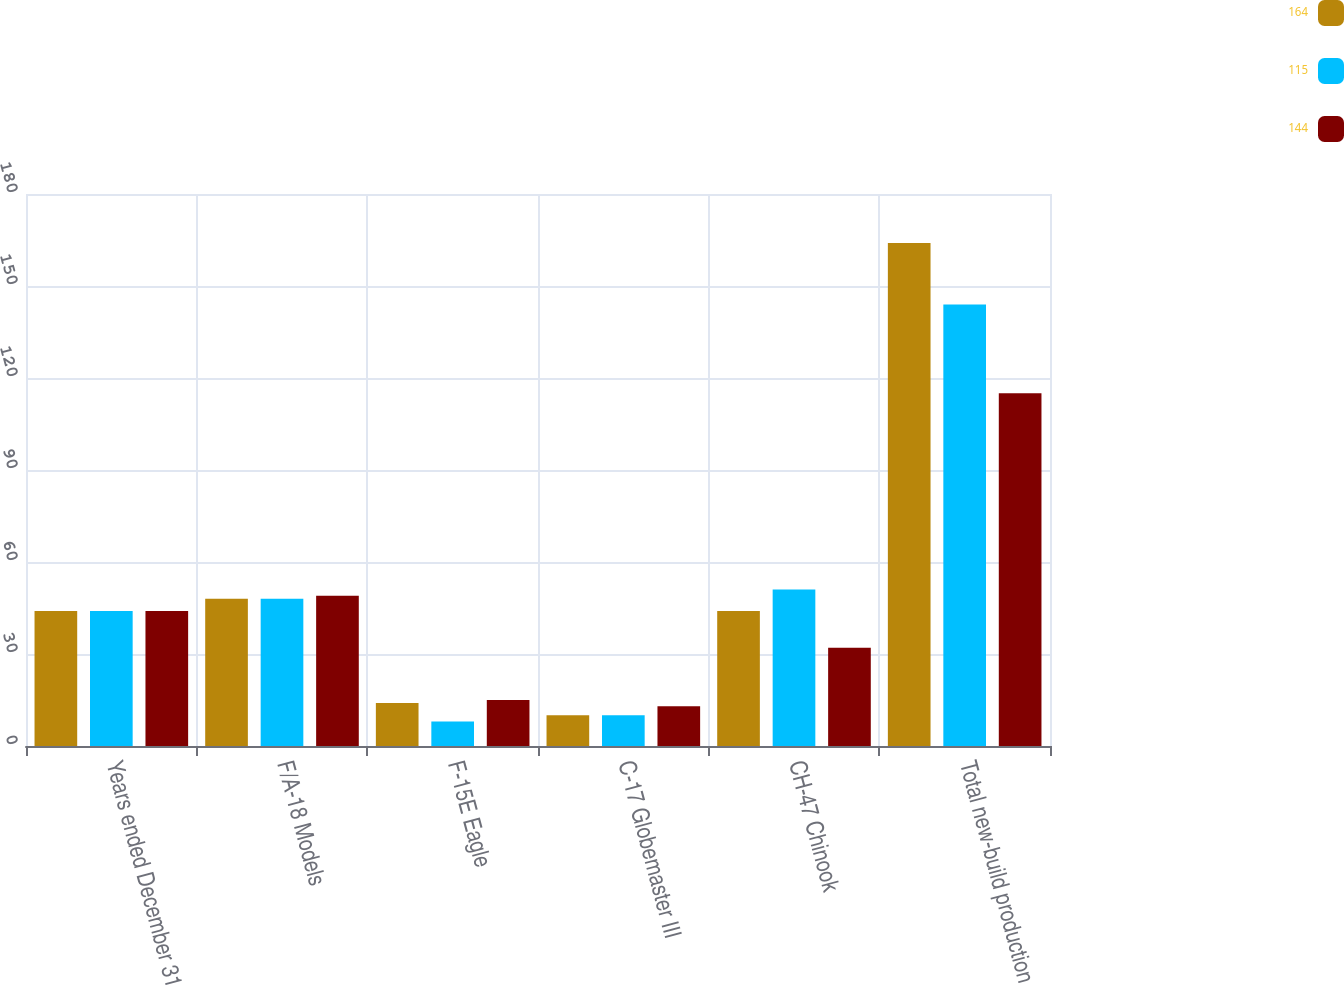<chart> <loc_0><loc_0><loc_500><loc_500><stacked_bar_chart><ecel><fcel>Years ended December 31<fcel>F/A-18 Models<fcel>F-15E Eagle<fcel>C-17 Globemaster III<fcel>CH-47 Chinook<fcel>Total new-build production<nl><fcel>164<fcel>44<fcel>48<fcel>14<fcel>10<fcel>44<fcel>164<nl><fcel>115<fcel>44<fcel>48<fcel>8<fcel>10<fcel>51<fcel>144<nl><fcel>144<fcel>44<fcel>49<fcel>15<fcel>13<fcel>32<fcel>115<nl></chart> 